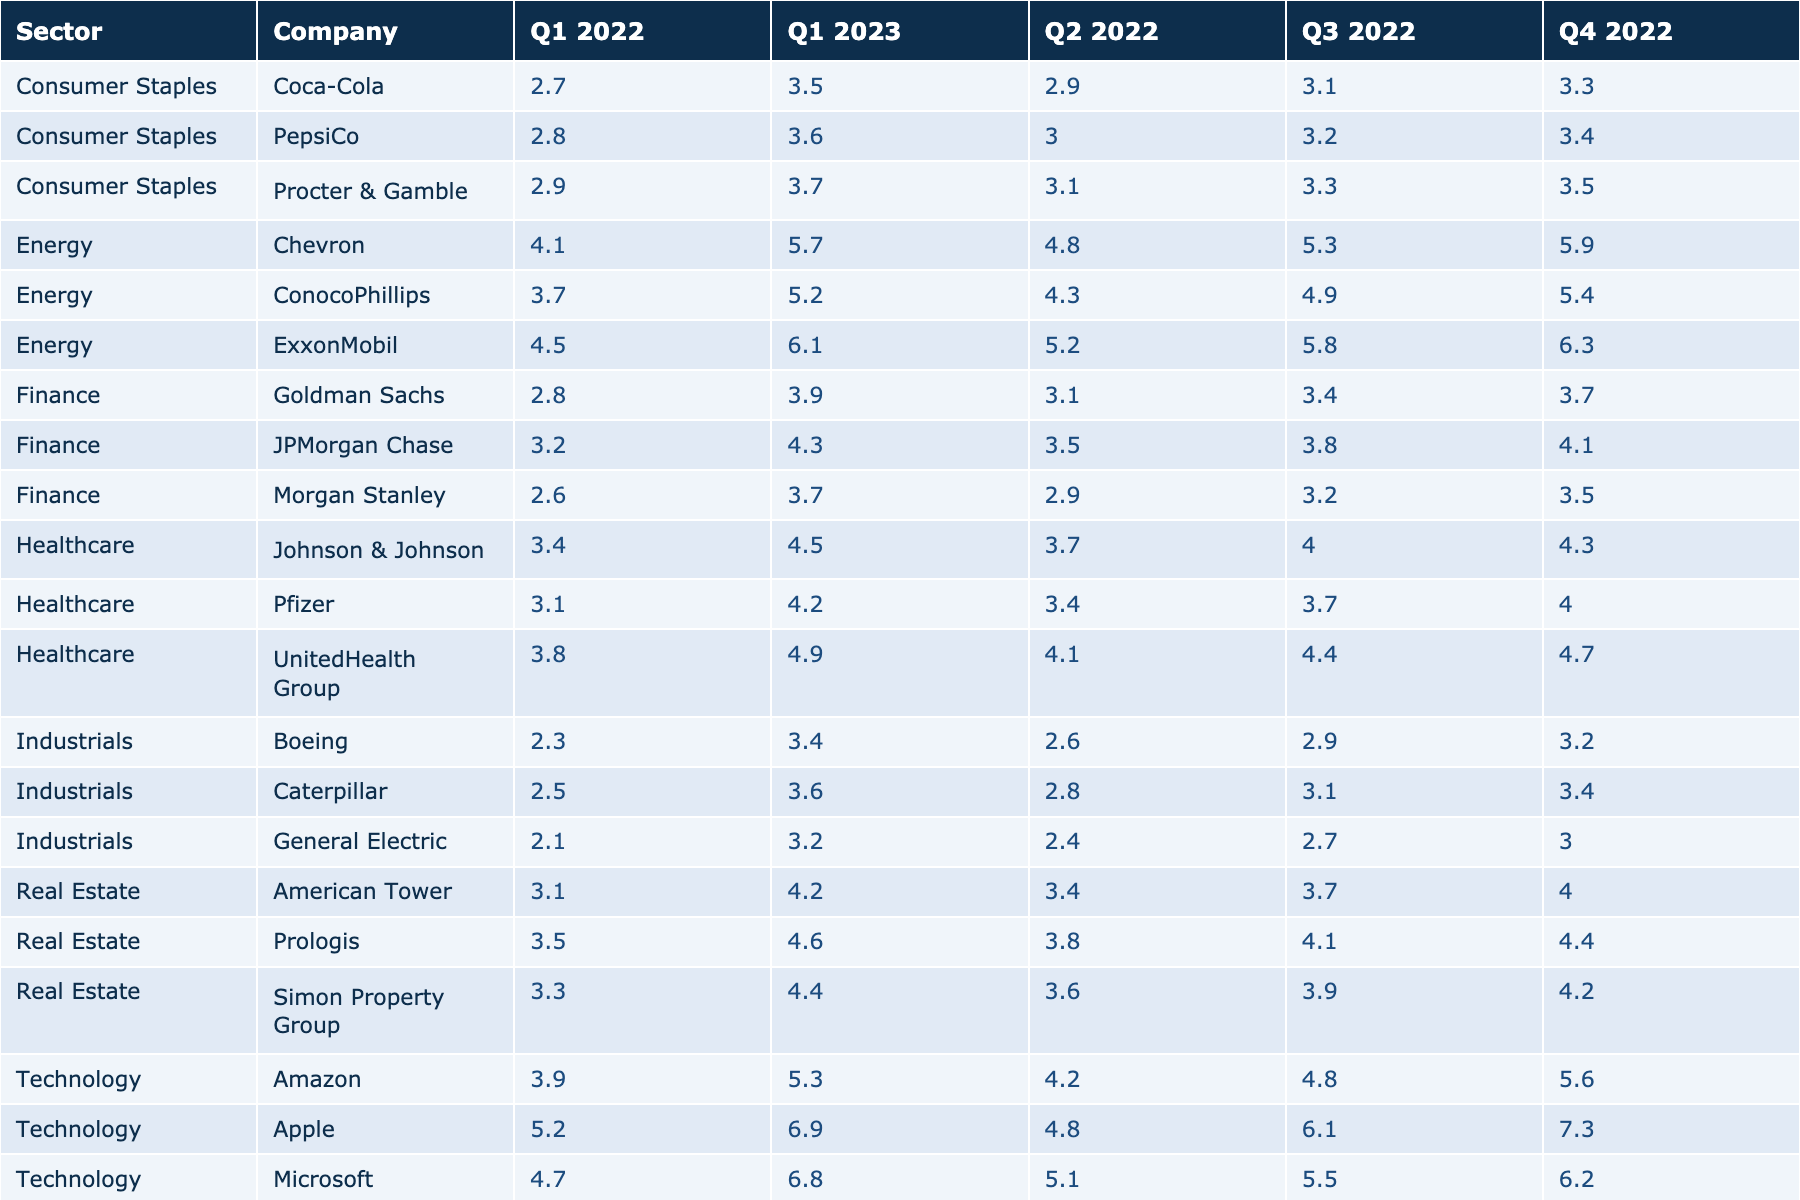What was the performance of Apple in Q1 2022? The table shows that Apple's performance in Q1 2022 was 5.2.
Answer: 5.2 Which sector had the highest average performance in Q4 2022? First, we calculate the average performance for each sector in Q4 2022: Technology (6.1, 6.2, 5.6), Finance (4.1, 3.7, 3.5), Energy (6.3, 5.9, 5.4), Healthcare (4.3, 4.0, 4.7), Consumer Staples (3.5, 3.3, 3.4), Industrials (3.2, 3.4, 3.0), Real Estate (4.2, 4.4, 4.0). The average performances are: Technology 6.1, Finance 3.8, Energy 5.8, Healthcare 4.3, Consumer Staples 3.4, Industrials 3.2, Real Estate 4.2. The highest average is in the Technology sector with 6.1.
Answer: Technology Is the performance of Amazon in Q2 2022 higher than that of ExxonMobil in the same quarter? The table shows that Amazon's performance in Q2 2022 was 4.2 while ExxonMobil’s was 5.2. Since 4.2 is less than 5.2, the statement is false.
Answer: No What is the total performance of the Finance sector across all quarters? We sum the performances of the companies in the Finance sector across all quarters: JPMorgan Chase (3.2 + 3.5 + 3.8 + 4.1 + 4.3) + Goldman Sachs (2.8 + 3.1 + 3.4 + 3.7 + 3.9) + Morgan Stanley (2.6 + 2.9 + 3.2 + 3.5 + 3.7) = 18 + 16.9 + 16.9 = 51.8.
Answer: 51.8 In which quarter did UnitedHealth Group have the lowest performance? Looking at UnitedHealth Group's performances: Q1 2022 (3.8), Q2 2022 (4.1), Q3 2022 (4.4), Q4 2022 (4.7), Q1 2023 (4.9), the lowest value is in Q1 2022 at 3.8.
Answer: Q1 2022 Which company in the Energy sector showed the most significant increase in performance from Q1 2022 to Q1 2023? We look at the performance change of each Energy company: ExxonMobil (4.5 to 6.1), Chevron (4.1 to 5.7), ConocoPhillips (3.7 to 5.2). The changes are: ExxonMobil (1.6), Chevron (1.6), ConocoPhillips (1.5). The greatest increase is 1.6, seen in both ExxonMobil and Chevron.
Answer: ExxonMobil and Chevron (1.6) 